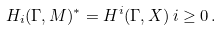Convert formula to latex. <formula><loc_0><loc_0><loc_500><loc_500>H _ { i } ( \Gamma , M ) ^ { \ast } = H ^ { i } ( \Gamma , X ) \, i \geq 0 \, .</formula> 